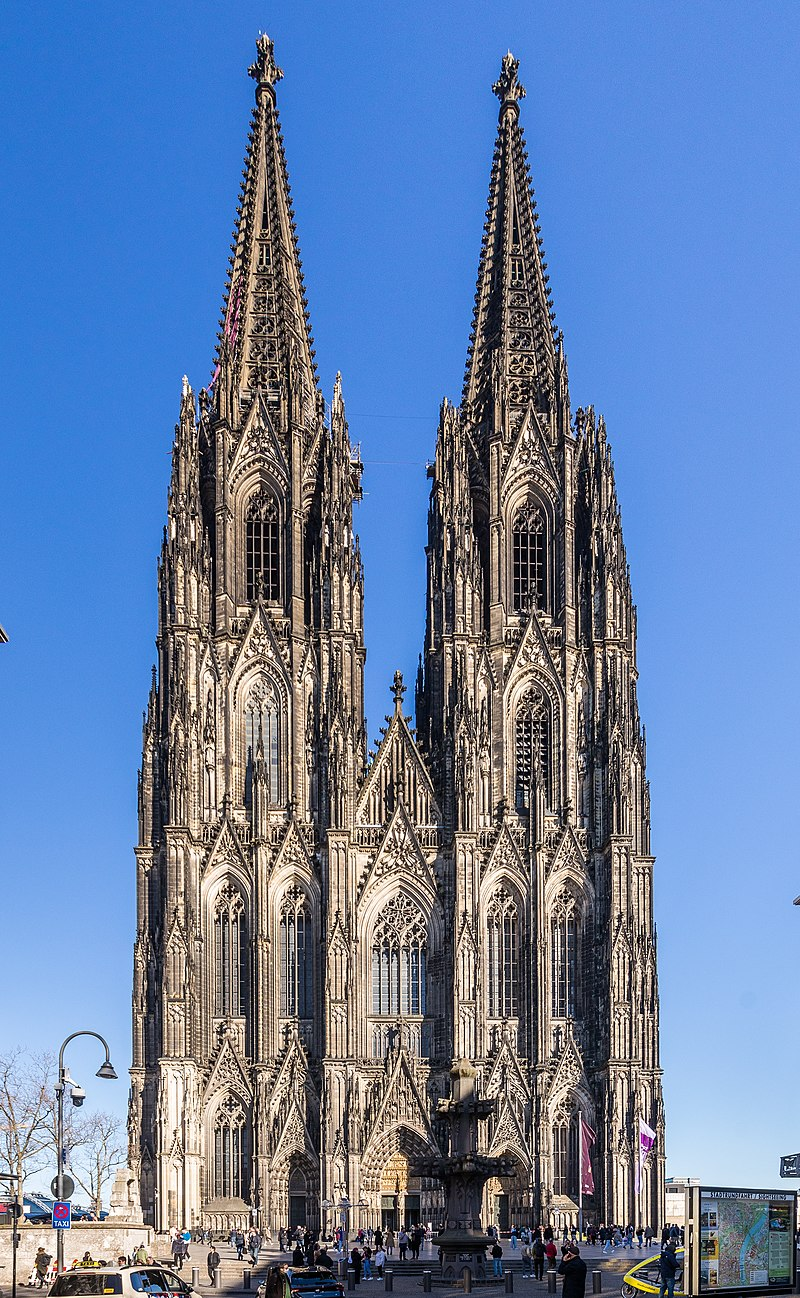Can you explain the significance of the architectural features seen in the cathedral? Certainly. The two spires of the Cologne Cathedral are characteristic of Gothic architecture, aiming to draw the eyes upward, towards the heavens, which is a typical element intended to inspire awe and spiritual reflection. The flying buttresses, visible along the sides, are not just decorative but also functional, as they support the high walls and allow for large stained glass windows which fill the interior with light. The intricate facades feature biblical narratives and saints, serving both an educational and inspirational purpose for viewers in times when literacy was not widespread. 